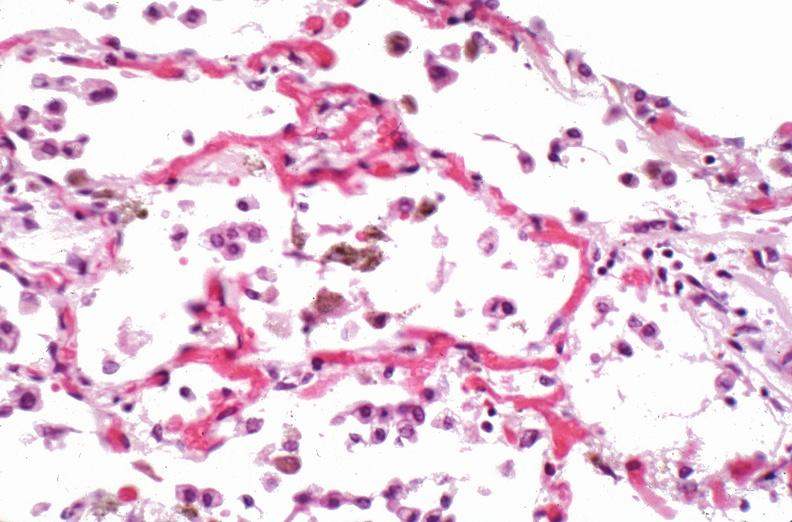s respiratory present?
Answer the question using a single word or phrase. Yes 